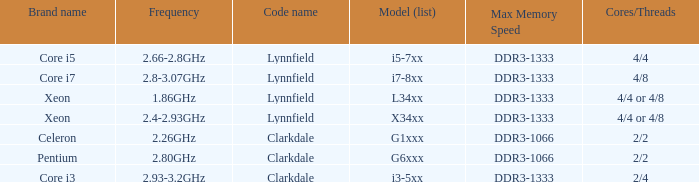Write the full table. {'header': ['Brand name', 'Frequency', 'Code name', 'Model (list)', 'Max Memory Speed', 'Cores/Threads'], 'rows': [['Core i5', '2.66-2.8GHz', 'Lynnfield', 'i5-7xx', 'DDR3-1333', '4/4'], ['Core i7', '2.8-3.07GHz', 'Lynnfield', 'i7-8xx', 'DDR3-1333', '4/8'], ['Xeon', '1.86GHz', 'Lynnfield', 'L34xx', 'DDR3-1333', '4/4 or 4/8'], ['Xeon', '2.4-2.93GHz', 'Lynnfield', 'X34xx', 'DDR3-1333', '4/4 or 4/8'], ['Celeron', '2.26GHz', 'Clarkdale', 'G1xxx', 'DDR3-1066', '2/2'], ['Pentium', '2.80GHz', 'Clarkdale', 'G6xxx', 'DDR3-1066', '2/2'], ['Core i3', '2.93-3.2GHz', 'Clarkdale', 'i3-5xx', 'DDR3-1333', '2/4']]} List the number of cores for ddr3-1333 with frequencies between 2.66-2.8ghz. 4/4. 